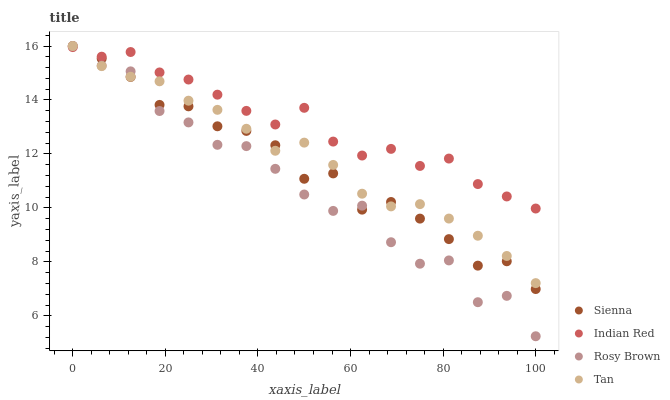Does Rosy Brown have the minimum area under the curve?
Answer yes or no. Yes. Does Indian Red have the maximum area under the curve?
Answer yes or no. Yes. Does Tan have the minimum area under the curve?
Answer yes or no. No. Does Tan have the maximum area under the curve?
Answer yes or no. No. Is Tan the smoothest?
Answer yes or no. Yes. Is Rosy Brown the roughest?
Answer yes or no. Yes. Is Rosy Brown the smoothest?
Answer yes or no. No. Is Tan the roughest?
Answer yes or no. No. Does Rosy Brown have the lowest value?
Answer yes or no. Yes. Does Tan have the lowest value?
Answer yes or no. No. Does Rosy Brown have the highest value?
Answer yes or no. Yes. Does Indian Red have the highest value?
Answer yes or no. No. Does Sienna intersect Rosy Brown?
Answer yes or no. Yes. Is Sienna less than Rosy Brown?
Answer yes or no. No. Is Sienna greater than Rosy Brown?
Answer yes or no. No. 